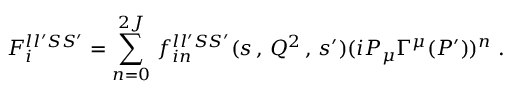<formula> <loc_0><loc_0><loc_500><loc_500>F _ { i } ^ { l l ^ { \prime } S S ^ { \prime } } = \sum _ { n = 0 } ^ { 2 J } \, f _ { i n } ^ { l l ^ { \prime } S S ^ { \prime } } ( s \, , \, Q ^ { 2 } \, , \, s ^ { \prime } ) ( i P _ { \mu } \Gamma ^ { \mu } ( P ^ { \prime } ) ) ^ { n } \, .</formula> 